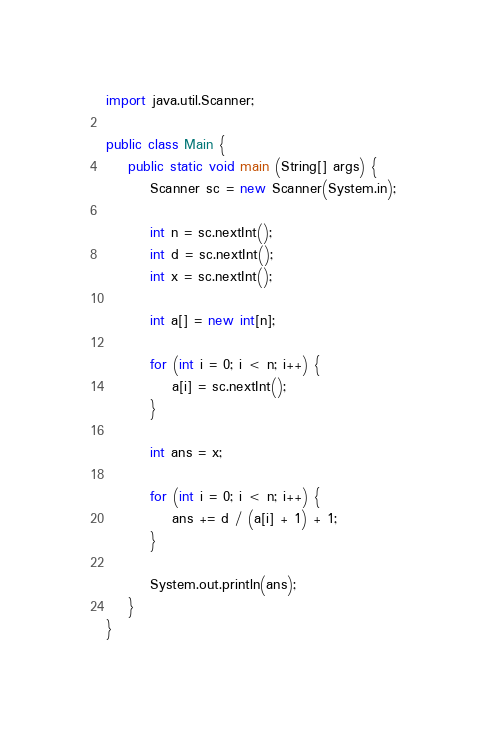Convert code to text. <code><loc_0><loc_0><loc_500><loc_500><_Java_>import java.util.Scanner;

public class Main {
	public static void main (String[] args) {
		Scanner sc = new Scanner(System.in);

		int n = sc.nextInt();
		int d = sc.nextInt();
		int x = sc.nextInt();
		
		int a[] = new int[n];
		
		for (int i = 0; i < n; i++) {
			a[i] = sc.nextInt();
		}
		
		int ans = x;
		
		for (int i = 0; i < n; i++) {
			ans += d / (a[i] + 1) + 1;
		}
		
		System.out.println(ans);
	}
}</code> 